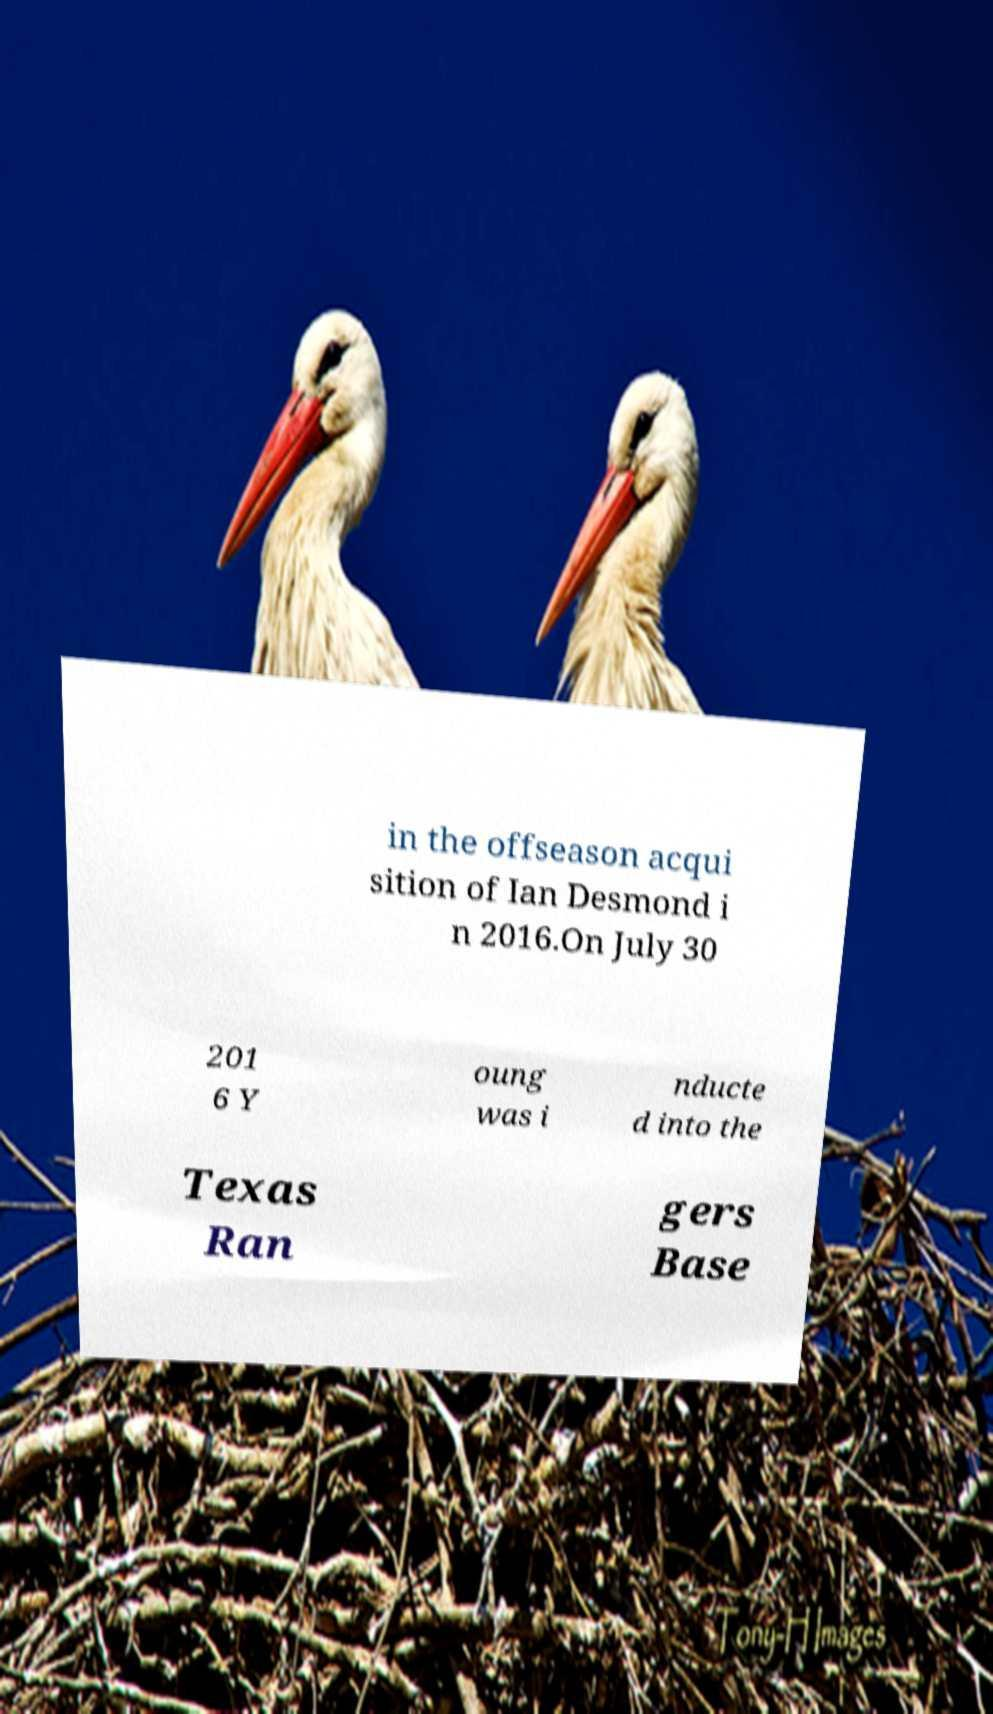I need the written content from this picture converted into text. Can you do that? in the offseason acqui sition of Ian Desmond i n 2016.On July 30 201 6 Y oung was i nducte d into the Texas Ran gers Base 